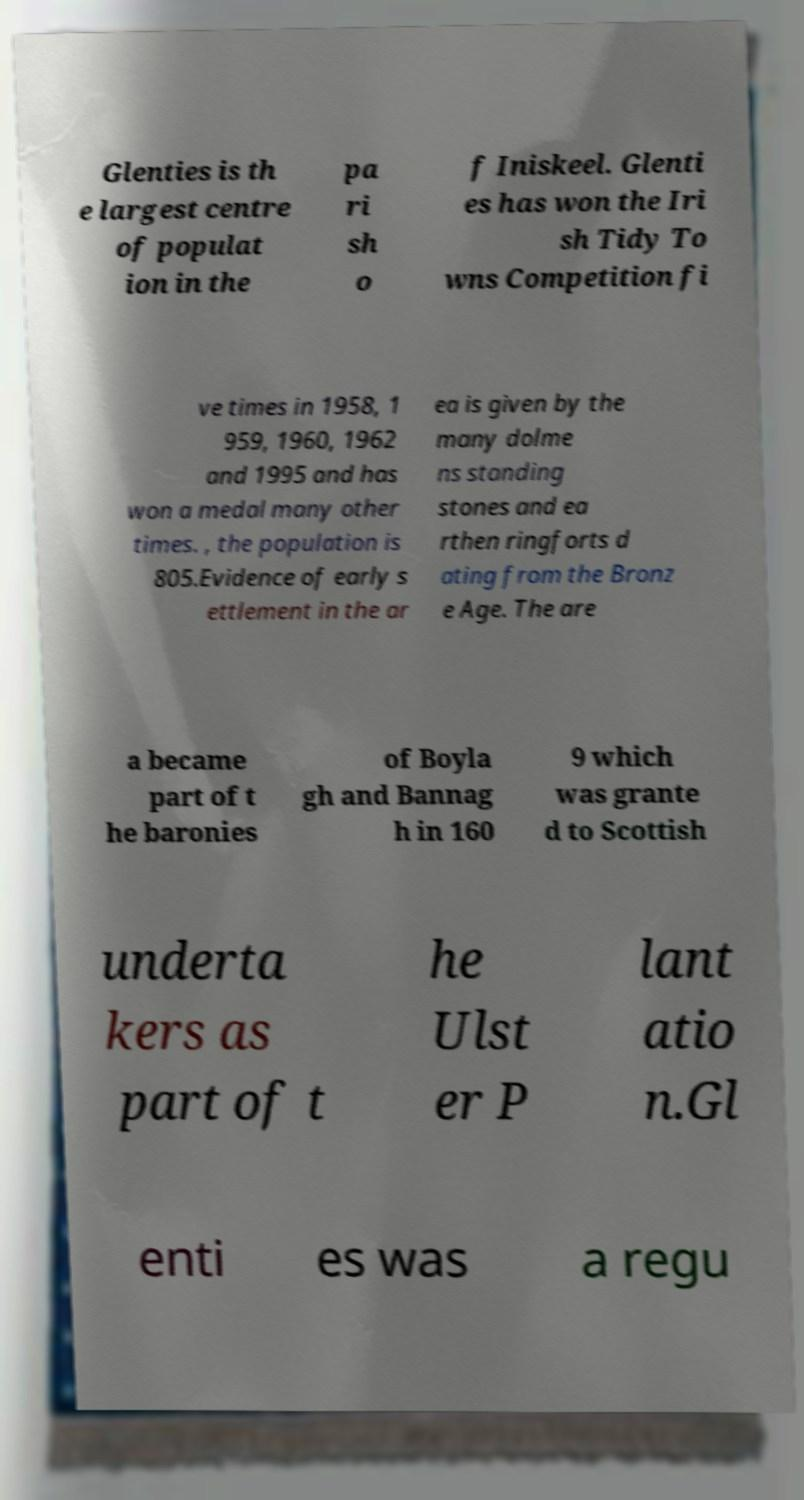What messages or text are displayed in this image? I need them in a readable, typed format. Glenties is th e largest centre of populat ion in the pa ri sh o f Iniskeel. Glenti es has won the Iri sh Tidy To wns Competition fi ve times in 1958, 1 959, 1960, 1962 and 1995 and has won a medal many other times. , the population is 805.Evidence of early s ettlement in the ar ea is given by the many dolme ns standing stones and ea rthen ringforts d ating from the Bronz e Age. The are a became part of t he baronies of Boyla gh and Bannag h in 160 9 which was grante d to Scottish underta kers as part of t he Ulst er P lant atio n.Gl enti es was a regu 